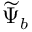<formula> <loc_0><loc_0><loc_500><loc_500>\widetilde { \Psi } _ { b }</formula> 